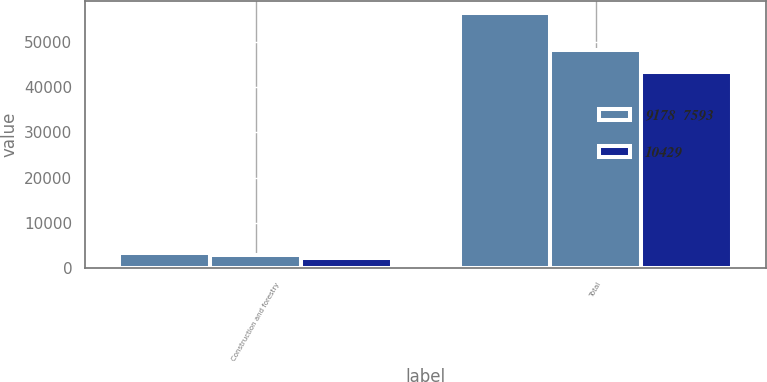Convert chart. <chart><loc_0><loc_0><loc_500><loc_500><stacked_bar_chart><ecel><fcel>Construction and forestry<fcel>Total<nl><fcel>nan<fcel>3365<fcel>56266<nl><fcel>9178  7593<fcel>2915<fcel>48207<nl><fcel>10429<fcel>2353<fcel>43267<nl></chart> 